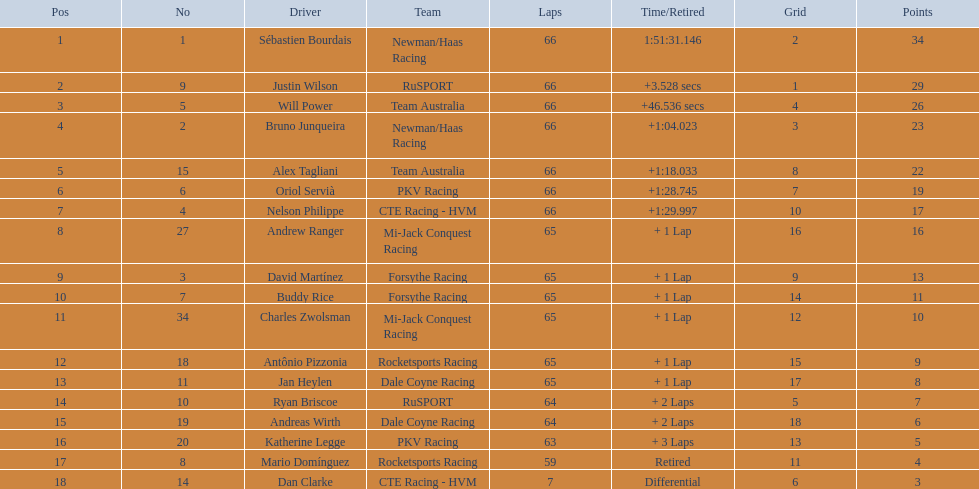Which drivers began the race in the top 10 positions? Sébastien Bourdais, Justin Wilson, Will Power, Bruno Junqueira, Alex Tagliani, Oriol Servià, Nelson Philippe, Ryan Briscoe, Dan Clarke. Among them, who managed to finish all 66 laps? Sébastien Bourdais, Justin Wilson, Will Power, Bruno Junqueira, Alex Tagliani, Oriol Servià, Nelson Philippe. Excluding those from team australia, who were the remaining drivers? Sébastien Bourdais, Justin Wilson, Bruno Junqueira, Oriol Servià, Nelson Philippe. Who among them finished over a minute after the champion? Bruno Junqueira, Oriol Servià, Nelson Philippe. Who had the highest car number among these drivers? Oriol Servià. 